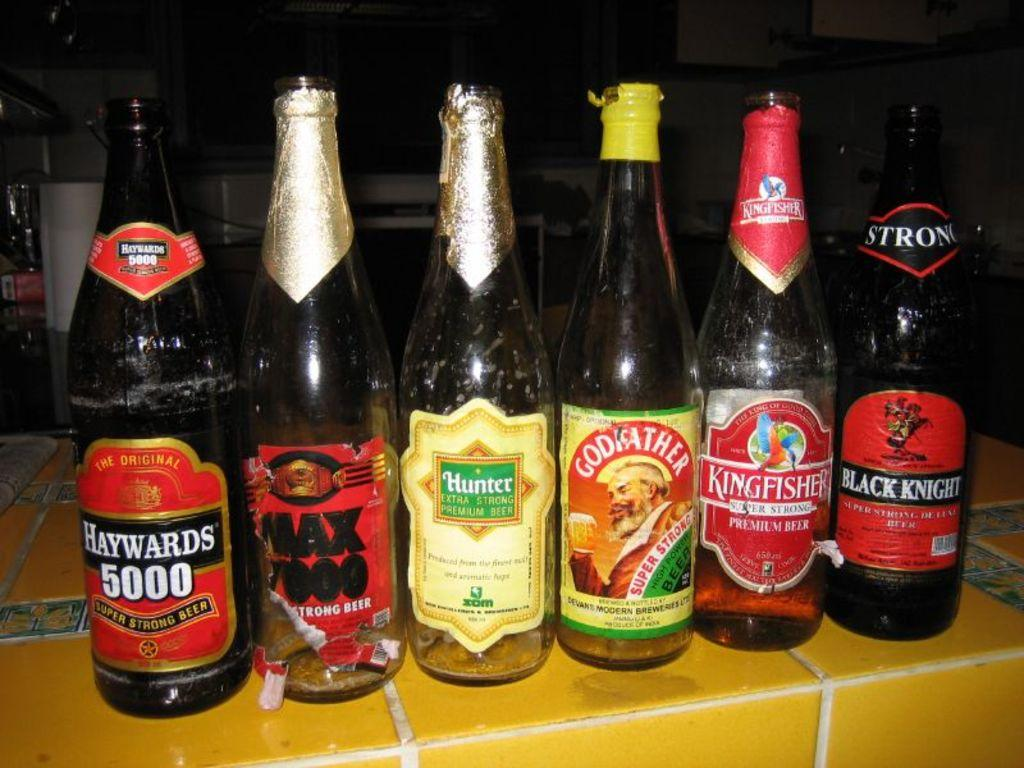<image>
Render a clear and concise summary of the photo. six bottles standing next to each other on a counter with one of them labeled 'haywards 5000' 